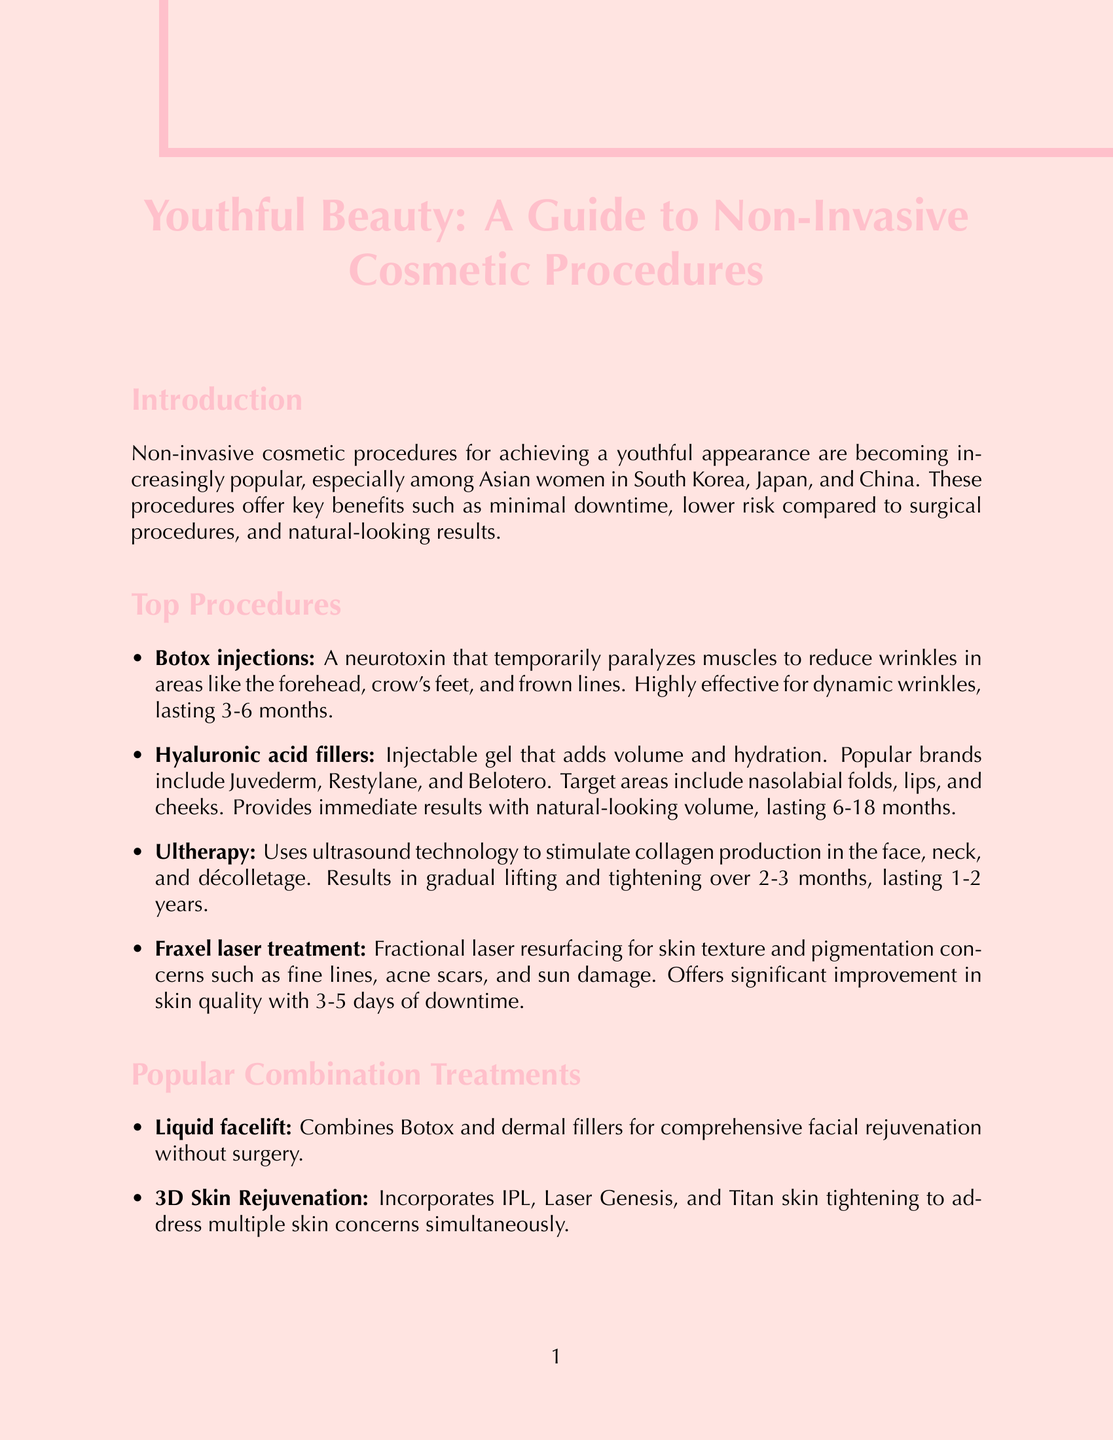what are the key benefits of non-invasive procedures? The document lists three key benefits: minimal downtime, lower risk compared to surgical procedures, and natural-looking results.
Answer: minimal downtime, lower risk compared to surgical procedures, natural-looking results which procedure is highly effective for dynamic wrinkles? The document states that Botox injections are highly effective for dynamic wrinkles.
Answer: Botox injections how long do hyaluronic acid fillers last? According to the document, hyaluronic acid fillers last between 6-18 months.
Answer: 6-18 months what is the risk associated with Asian skin in cosmetic procedures? The document mentions a higher risk of post-inflammatory hyperpigmentation associated with Asian skin.
Answer: higher risk of post-inflammatory hyperpigmentation what is a popular combination treatment mentioned in the document? The document lists "Liquid facelift" as a popular combination treatment.
Answer: Liquid facelift how long does Ultherapy results last? The document states that the results of Ultherapy last for 1-2 years.
Answer: 1-2 years what are the components of the 3D Skin Rejuvenation treatment? The document describes three components of the 3D Skin Rejuvenation treatment as IPL, Laser Genesis, and Titan skin tightening.
Answer: IPL, Laser Genesis, Titan skin tightening how should one maintain skin after cosmetic procedures? The document suggests a skincare routine that includes gentle cleansing, hydration with hyaluronic acid serums, and broad-spectrum sunscreen (SPF 50+).
Answer: gentle cleansing, hydration with hyaluronic acid serums, broad-spectrum sunscreen (SPF 50+) what questions should be asked when choosing a provider for cosmetic procedures? The document recommends asking about the number of procedures performed on Asian patients, encountered complications, and recommended treatment combinations.
Answer: How many procedures have you performed on Asian patients? What complications have you encountered and how were they managed? What combination of treatments do you recommend for my specific concerns? 